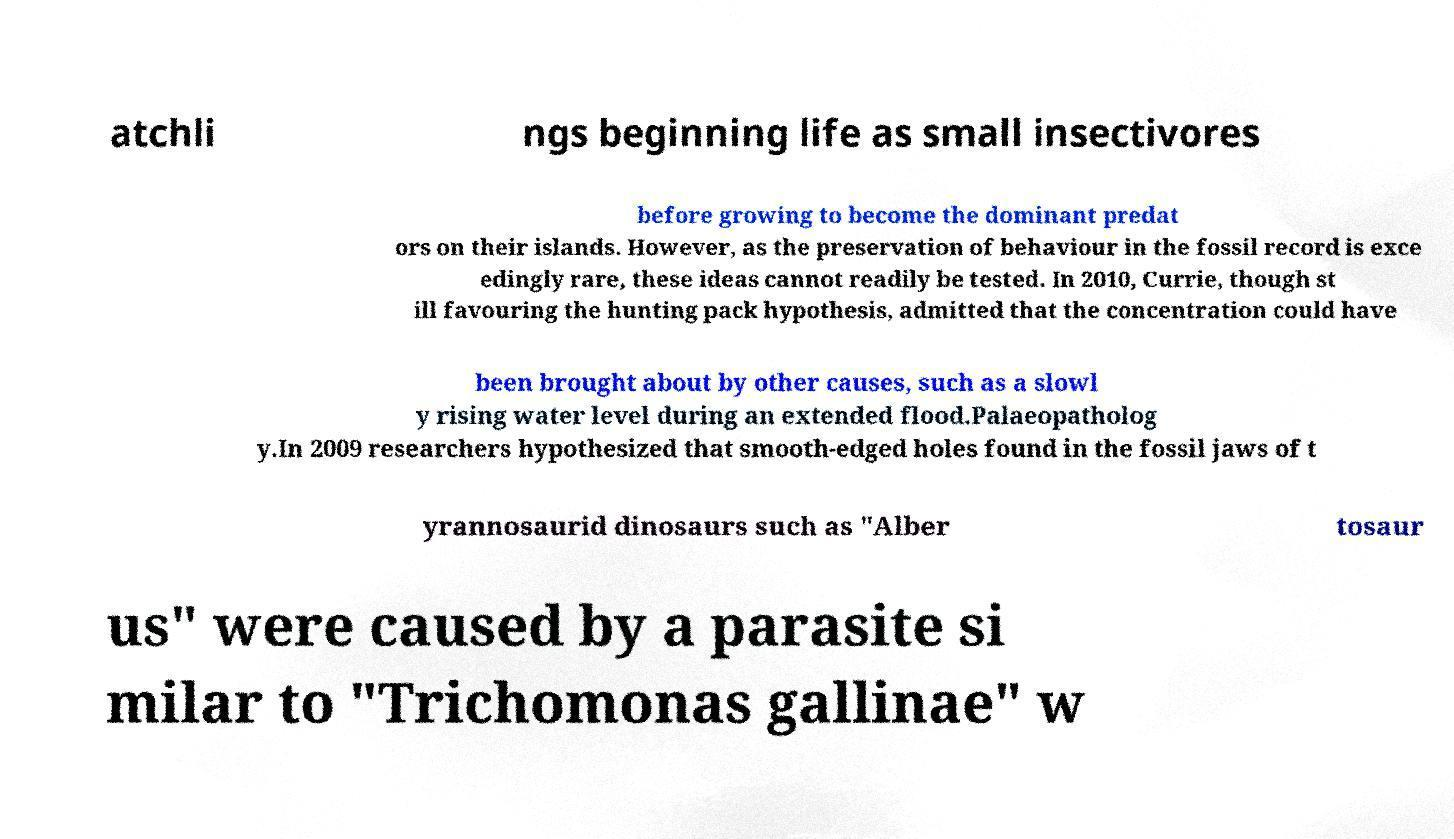Could you extract and type out the text from this image? atchli ngs beginning life as small insectivores before growing to become the dominant predat ors on their islands. However, as the preservation of behaviour in the fossil record is exce edingly rare, these ideas cannot readily be tested. In 2010, Currie, though st ill favouring the hunting pack hypothesis, admitted that the concentration could have been brought about by other causes, such as a slowl y rising water level during an extended flood.Palaeopatholog y.In 2009 researchers hypothesized that smooth-edged holes found in the fossil jaws of t yrannosaurid dinosaurs such as "Alber tosaur us" were caused by a parasite si milar to "Trichomonas gallinae" w 